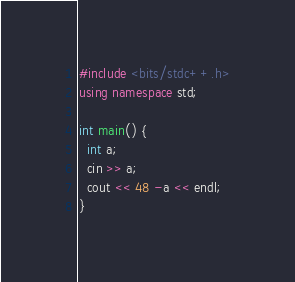<code> <loc_0><loc_0><loc_500><loc_500><_C++_>#include <bits/stdc++.h>
using namespace std;

int main() {
  int a;
  cin >> a;
  cout << 48 -a << endl;
}</code> 